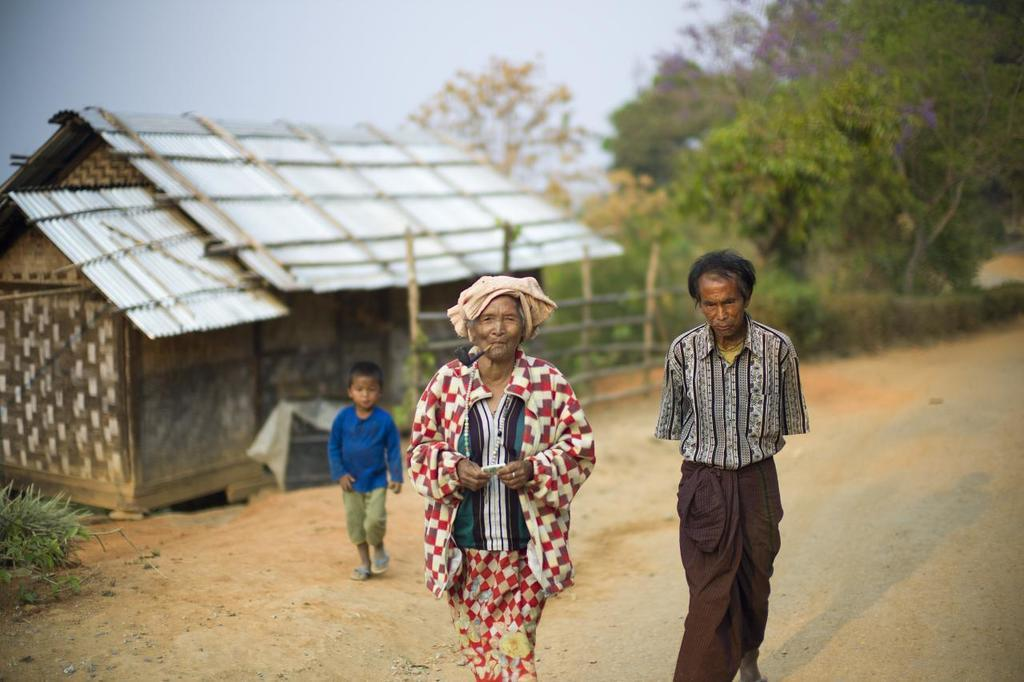How many people are present in the image? There are three people in the image: a man, a woman, and a child. What are the people in the image doing? The people are walking on the road. What can be seen in the background of the image? There is a house, plants, a fence, trees, and the sky visible in the background of the image. How many oranges are being carried by the child in the image? There are no oranges present in the image. What nation is depicted in the image? The image does not depict a specific nation; it shows a man, a woman, a child, and a background scene. 